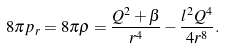Convert formula to latex. <formula><loc_0><loc_0><loc_500><loc_500>8 \pi p _ { r } = 8 \pi \rho = \frac { Q ^ { 2 } + \beta } { r ^ { 4 } } - \frac { l ^ { 2 } Q ^ { 4 } } { 4 r ^ { 8 } } .</formula> 